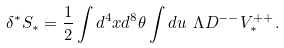<formula> <loc_0><loc_0><loc_500><loc_500>\delta ^ { * } S _ { * } = \frac { 1 } { 2 } \int d ^ { 4 } x d ^ { 8 } \theta \int d u \ \Lambda D ^ { - - } V ^ { + + } _ { * } .</formula> 